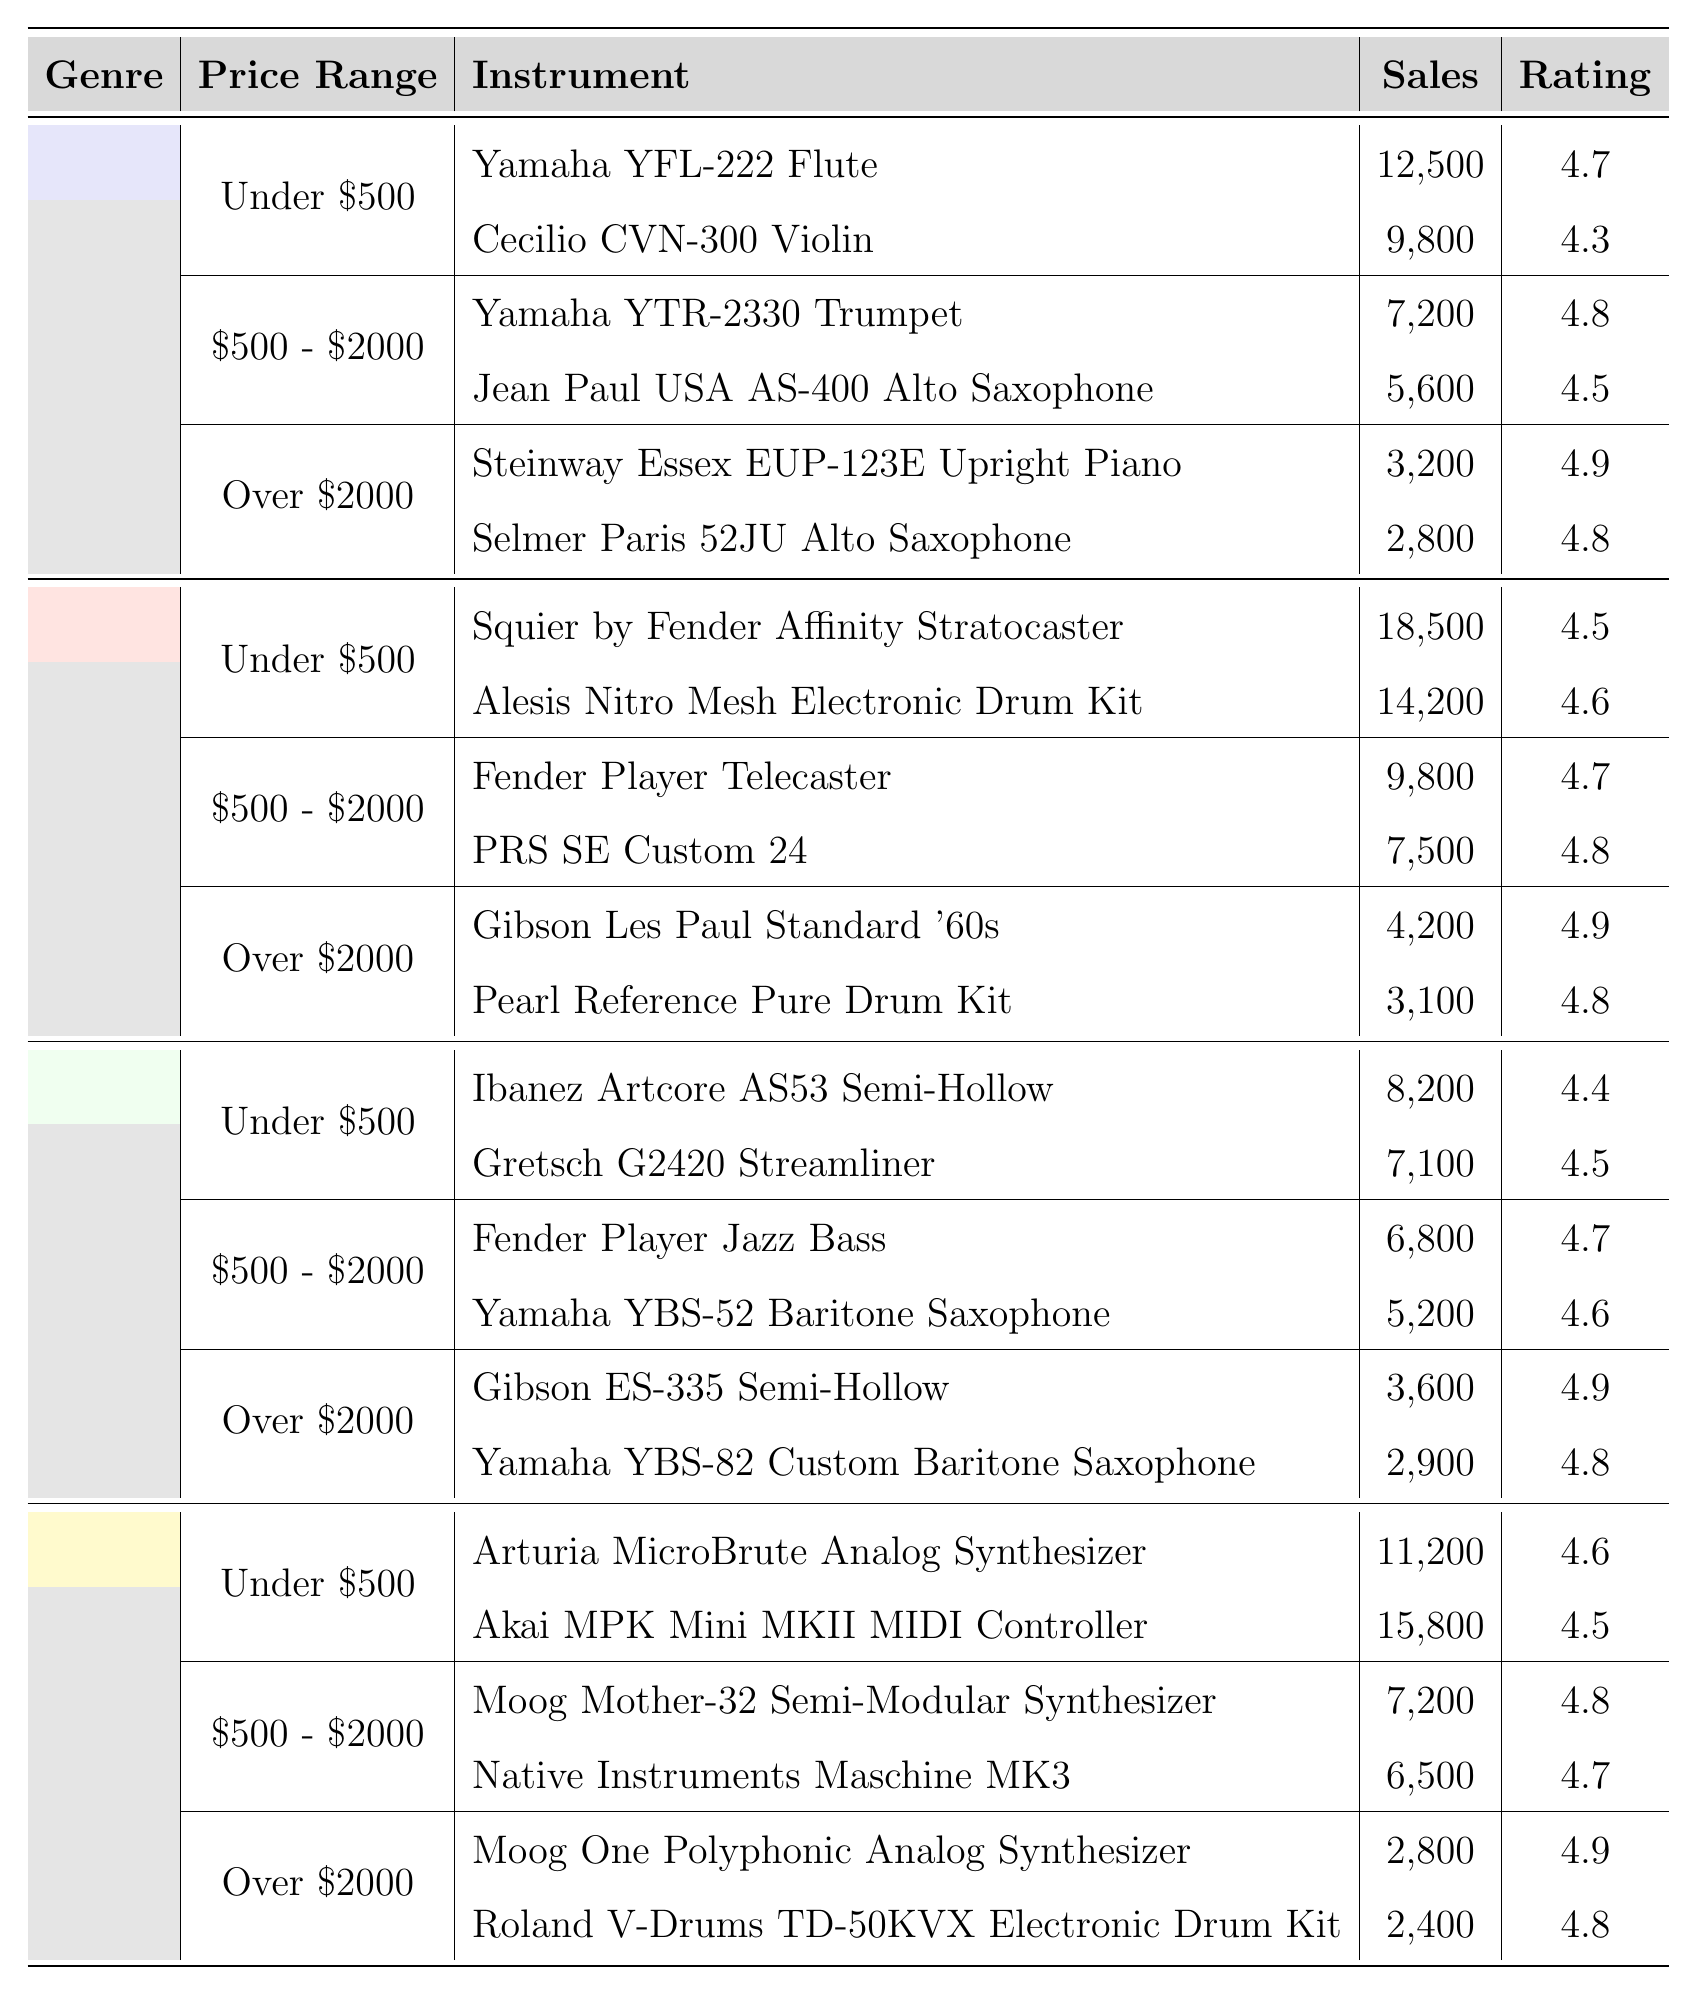Which musical instrument in the Rock genre sold the most under $500? The table shows that the Squier by Fender Affinity Stratocaster had the highest sales of 18,500 in the Under $500 category within the Rock genre.
Answer: Squier by Fender Affinity Stratocaster What was the average sales of electronic instruments listed in the "$500 - $2000" price range? In the $500 - $2000 range, the sales figures for Musical Instruments are 7,200 for Moog Mother-32 and 6,500 for Native Instruments Maschine MK3. The average sales can be calculated as (7,200 + 6,500) / 2 = 6,850.
Answer: 6850 Is the average rating of Classical instruments in the "Under $500" range above or below 4.5? The average rating of the two instruments (Yamaha YFL-222 Flute = 4.7 and Cecilio CVN-300 Violin = 4.3) in the Under $500 range is (4.7 + 4.3) / 2 = 4.5, which meets the threshold. Therefore, it is neither above nor below.
Answer: Neither How many instruments in the Jazz genre have an average rating of 4.8 or higher across all price ranges? Looking at the Jazz genre, the following instruments have ratings of 4.8 or higher: Gibson ES-335 Semi-Hollow (4.9), Yamaha YBS-82 Custom Baritone Saxophone (4.8), Fender Player Jazz Bass (4.7) does not qualify, but Yamaha YBS-52 Baritone Saxophone (4.6) does not qualify either. Totaling these, we find there are 2 qualifying instruments (Gibson ES-335 semi-hollow and Yamaha YBS-82).
Answer: 2 What is the highest selling instrument in the Over $2000 price range across all genres? The table indicates that the highest selling instrument in the Over $2000 price range belongs to the Classical genre: Steinway Essex EUP-123E Upright Piano with sales of 3,200, which is greater than any other instrument in this price range from all genres.
Answer: Steinway Essex EUP-123E Upright Piano What is the difference in sales between the top-selling instrument in Rock under $500 and Jazz under $500? The top-selling instrument in Rock under $500 is the Squier by Fender Affinity Stratocaster with sales of 18,500, while in Jazz under $500, the highest is Ibanez Artcore AS53 Semi-Hollow with 8,200. The difference in sales is 18,500 - 8,200 = 10,300.
Answer: 10300 Which genres have instruments rated 4.9? By assessing the table, we find that both Classical (Steinway Essex EUP-123E Piano, 4.9 rating) and Rock (Gibson Les Paul Standard '60s, 4.9 rating) genres have instruments rated 4.9. Therefore, the genres are Classical and Rock.
Answer: Classical and Rock What is the total sales of top-selling instruments in the `Over $2000` category across all genres? The total sales for Over $2000 are Steinway Essex EUP-123E Upright Piano (3,200) + Selmer Paris 52JU Alto Saxophone (2,800) + Gibson Les Paul Standard '60s (4,200) + Pearl Reference Pure Drum Kit (3,100) + Gibson ES-335 Semi-Hollow (3,600) + Yamaha YBS-82 Custom Baritone Saxophone (2,900) = 20,900.
Answer: 20900 Which instrument has the highest average rating across all genres? By reviewing the table, the highest average rating of 4.9 belongs to both the Steinway Essex EUP-123E Upright Piano and the Gibson Les Paul Standard ‘60s. Therefore, both have the highest average rating.
Answer: Steinway Essex EUP-123E Upright Piano and Gibson Les Paul Standard ‘60s 